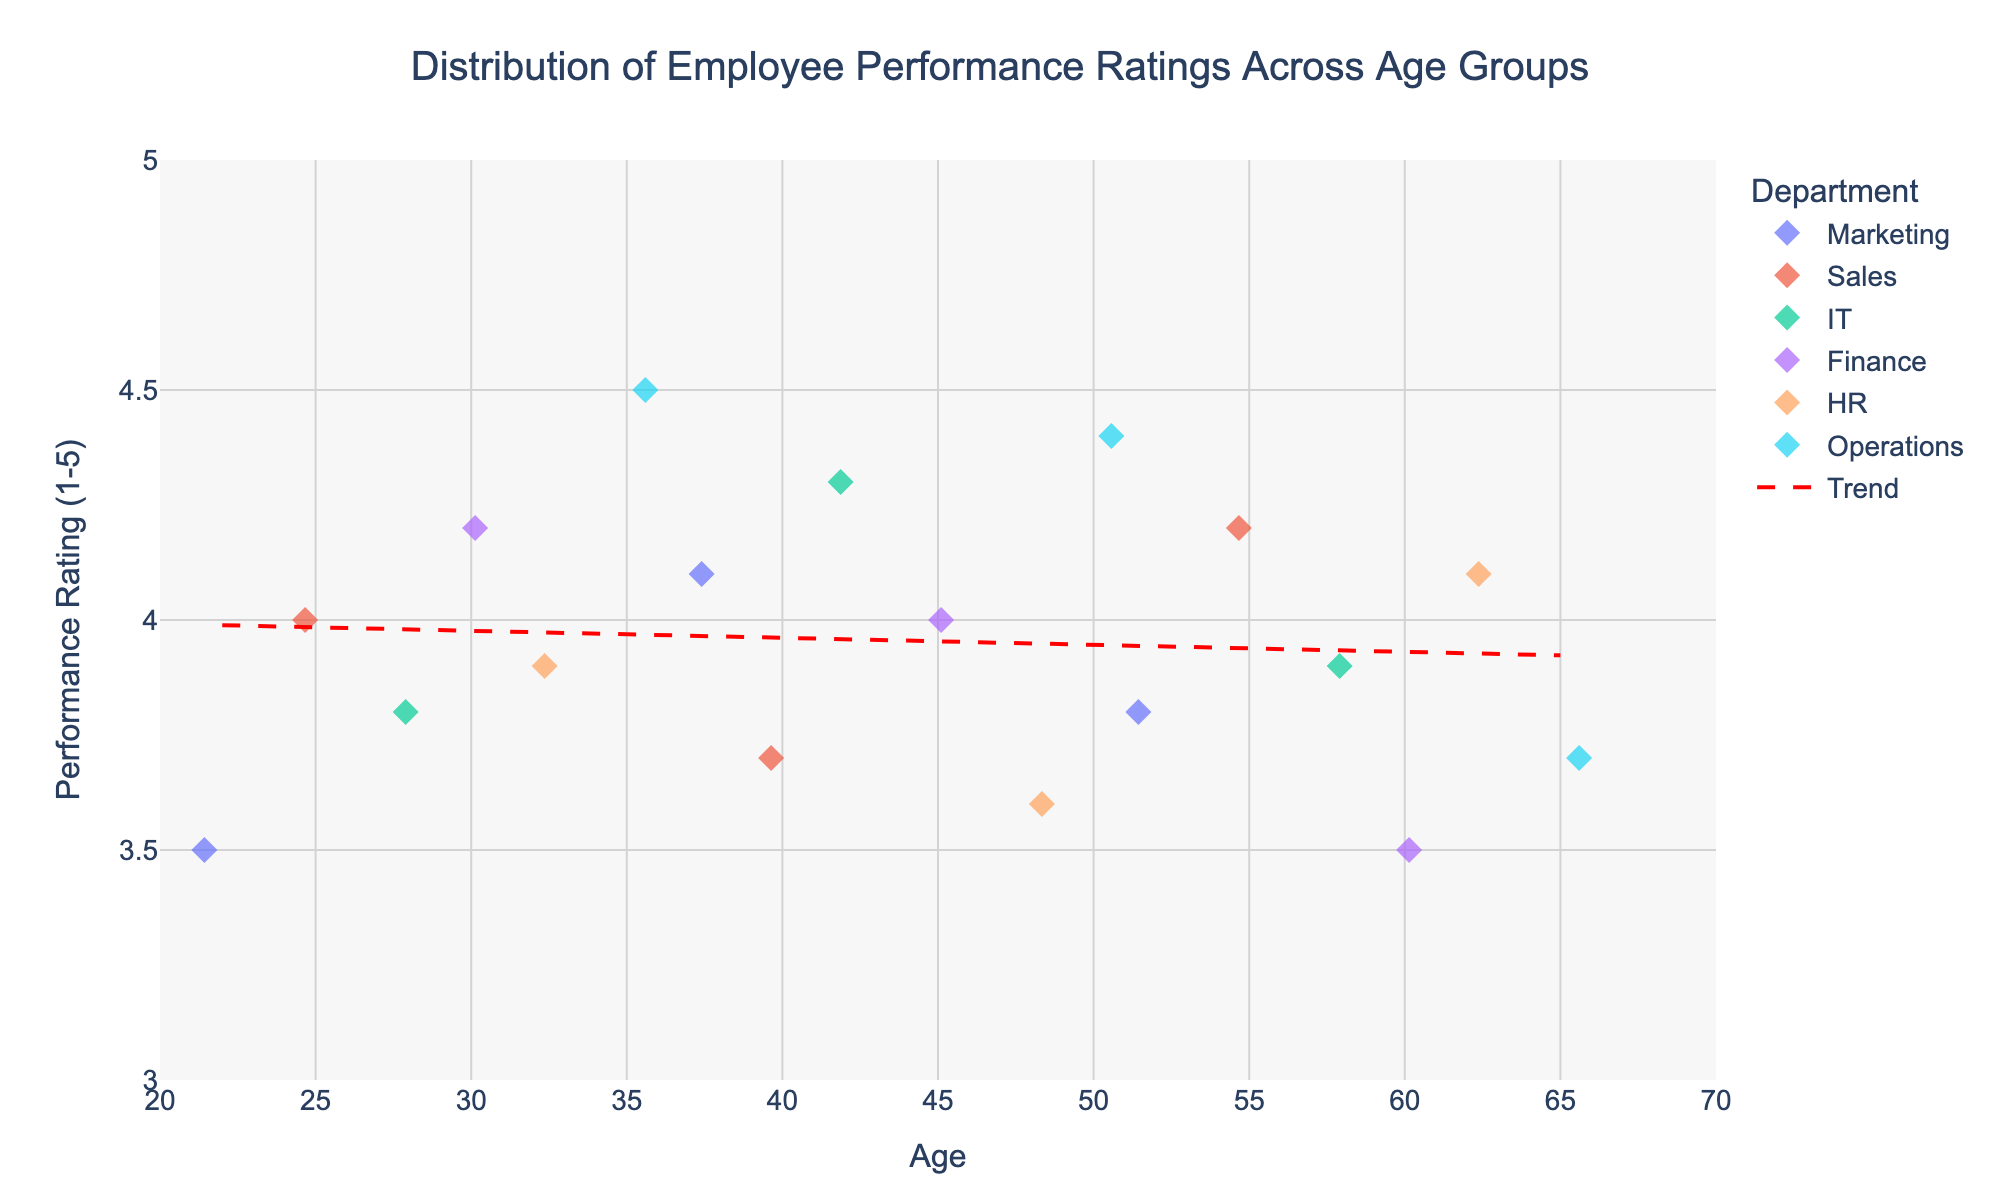What is the title of the plot? The title is displayed prominently at the top of the plot. It summarizes the main focus of the visual.
Answer: Distribution of Employee Performance Ratings Across Age Groups What is the range for the Performance Ratings axis? The Performance Ratings axis (vertical) ranges from 3.0 to 5.0, as indicated by the tick marks and the grid lines on the y-axis.
Answer: 3.0 to 5.0 Which department has the highest performance rating? By looking at the highest point on the y-axis and identifying its corresponding department color and label, the Operations department has the highest rating of 4.5.
Answer: Operations How many data points are there for the IT department? Count the number of markers (data points) with the color attributed to the IT department in the legend. There are three such points.
Answer: 3 What color represents the Marketing department? Refer to the legend on the figure that maps colors to department names. Marketing is represented by purple markers.
Answer: Purple What is the average Performance Rating for employees aged 45 to 55? Identify data points within the age range of 45 to 55. Calculate the average of their Performance Ratings: (4.0, 3.6, 4.2) -> (4.0 + 3.6 + 4.2) / 3 = 3.93
Answer: 3.93 Does the trend line indicate an overall increase or decrease in performance rating with age? The red dashed trend line shows the general direction of the data. It has a slight upward slope, indicating an overall increase in performance rating with age.
Answer: Increase Which age group has the most varied performance ratings? Look for age groups where the spread of performance ratings (distance between the lowest and highest ratings) is the largest. The group aged 22 has a spread from 3.5 to 4.1, indicating high variation.
Answer: Age 22 Which two departments have the closest average performance ratings? Calculate the average performance rating for each department and compare them. HR (3.9 + 4.1 + 3.6) / 3 ≈ 3.87 and IT (3.8 + 4.3 + 3.9) / 3 ≈ 4.00 are closest in average ratings.
Answer: HR and IT What is the performance rating of the youngest employee in the plot? Find the data point corresponding to the lowest age value, which is 22. The performance rating for this age is 3.5.
Answer: 3.5 